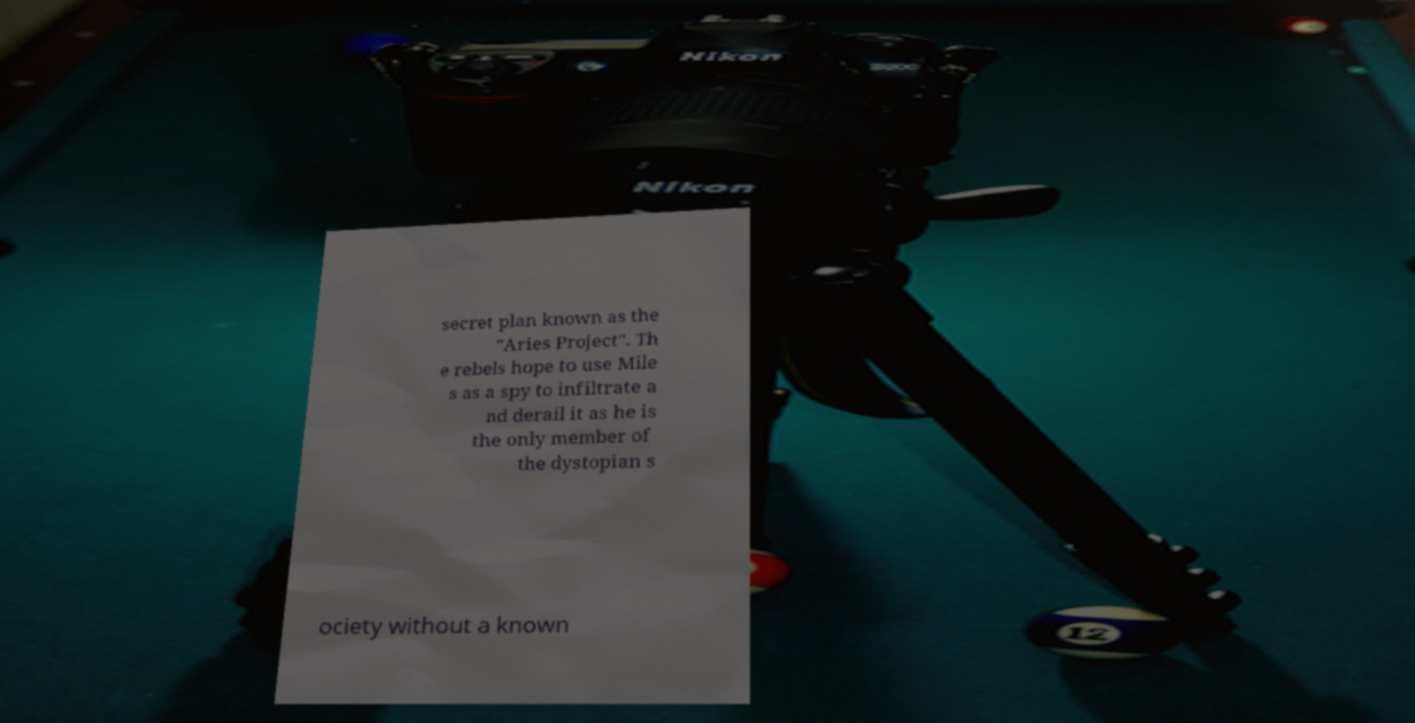Can you read and provide the text displayed in the image?This photo seems to have some interesting text. Can you extract and type it out for me? secret plan known as the "Aries Project". Th e rebels hope to use Mile s as a spy to infiltrate a nd derail it as he is the only member of the dystopian s ociety without a known 